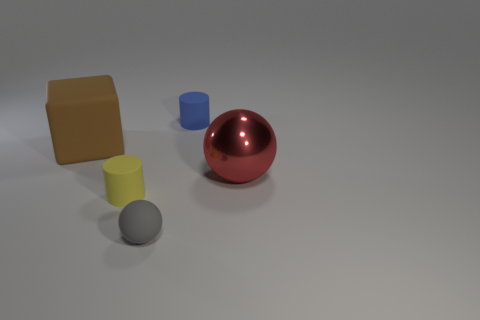Are there fewer rubber things than green spheres?
Keep it short and to the point. No. Is there any other thing that is the same size as the gray ball?
Keep it short and to the point. Yes. There is a tiny thing that is the same shape as the large shiny object; what is its material?
Ensure brevity in your answer.  Rubber. Is the number of big yellow metal cubes greater than the number of small rubber cylinders?
Your answer should be compact. No. How many other things are there of the same color as the large rubber block?
Offer a terse response. 0. Do the tiny gray ball and the thing that is behind the big brown rubber thing have the same material?
Offer a terse response. Yes. How many matte cylinders are to the right of the big thing that is on the left side of the ball that is in front of the red object?
Make the answer very short. 2. Are there fewer brown cubes to the right of the tiny gray matte sphere than tiny blue rubber cylinders that are in front of the tiny yellow matte cylinder?
Give a very brief answer. No. What number of other things are the same material as the big sphere?
Provide a succinct answer. 0. What is the material of the brown cube that is the same size as the red metallic object?
Your answer should be compact. Rubber. 